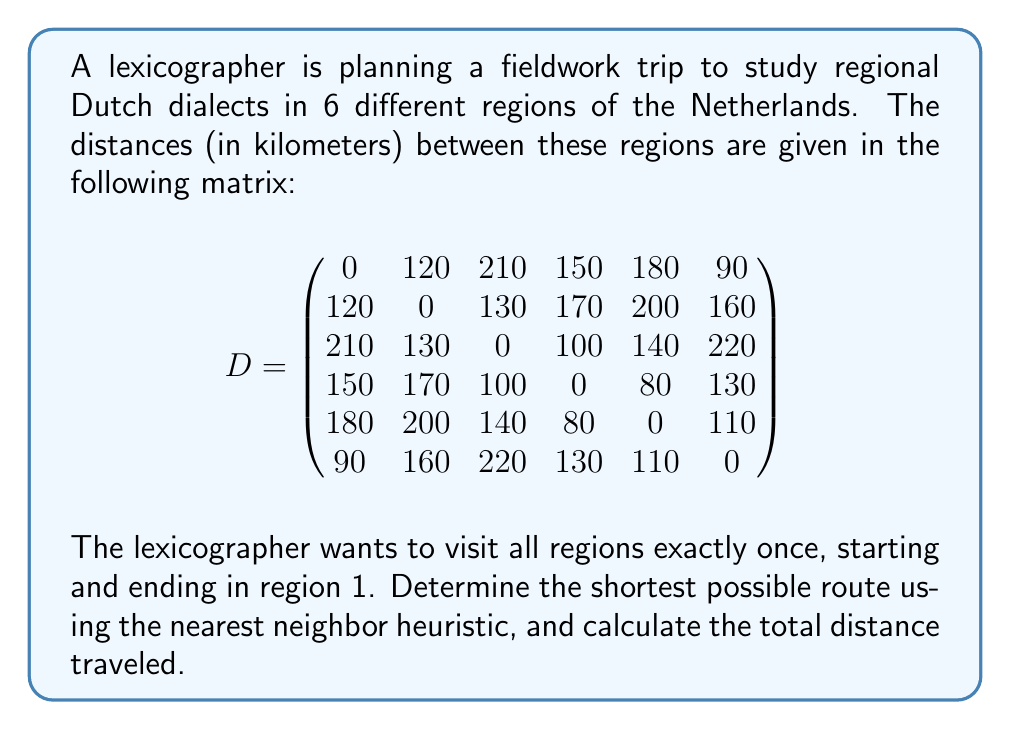Provide a solution to this math problem. To solve this problem, we'll use the nearest neighbor heuristic, which is a greedy algorithm that always chooses the closest unvisited region as the next destination. Here's the step-by-step process:

1. Start at region 1.

2. Find the nearest unvisited region from region 1:
   Region 6 is closest with a distance of 90 km.

3. Move to region 6 and find the nearest unvisited region:
   Region 5 is closest with a distance of 110 km.

4. Move to region 5 and find the nearest unvisited region:
   Region 4 is closest with a distance of 80 km.

5. Move to region 4 and find the nearest unvisited region:
   Region 3 is closest with a distance of 100 km.

6. Move to region 3 and find the nearest unvisited region:
   Region 2 is the only remaining unvisited region, with a distance of 130 km.

7. Finally, return to region 1 from region 2, with a distance of 120 km.

The complete route is: 1 → 6 → 5 → 4 → 3 → 2 → 1

To calculate the total distance:
$$\text{Total distance} = 90 + 110 + 80 + 100 + 130 + 120 = 630 \text{ km}$$

Note that while this heuristic provides a feasible solution, it may not always yield the globally optimal route. However, it is computationally efficient and often produces good approximations for the Traveling Salesman Problem.
Answer: The shortest route using the nearest neighbor heuristic is 1 → 6 → 5 → 4 → 3 → 2 → 1, with a total distance of 630 km. 